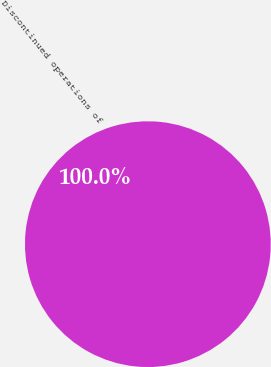<chart> <loc_0><loc_0><loc_500><loc_500><pie_chart><fcel>Discontinued operations of<nl><fcel>100.0%<nl></chart> 